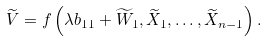Convert formula to latex. <formula><loc_0><loc_0><loc_500><loc_500>\widetilde { V } = f \left ( \lambda b _ { 1 1 } + \widetilde { W } _ { 1 } , \widetilde { X } _ { 1 } , \dots , \widetilde { X } _ { n - 1 } \right ) .</formula> 